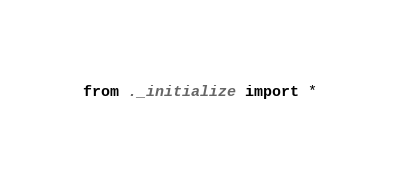Convert code to text. <code><loc_0><loc_0><loc_500><loc_500><_Python_>from ._initialize import *
</code> 